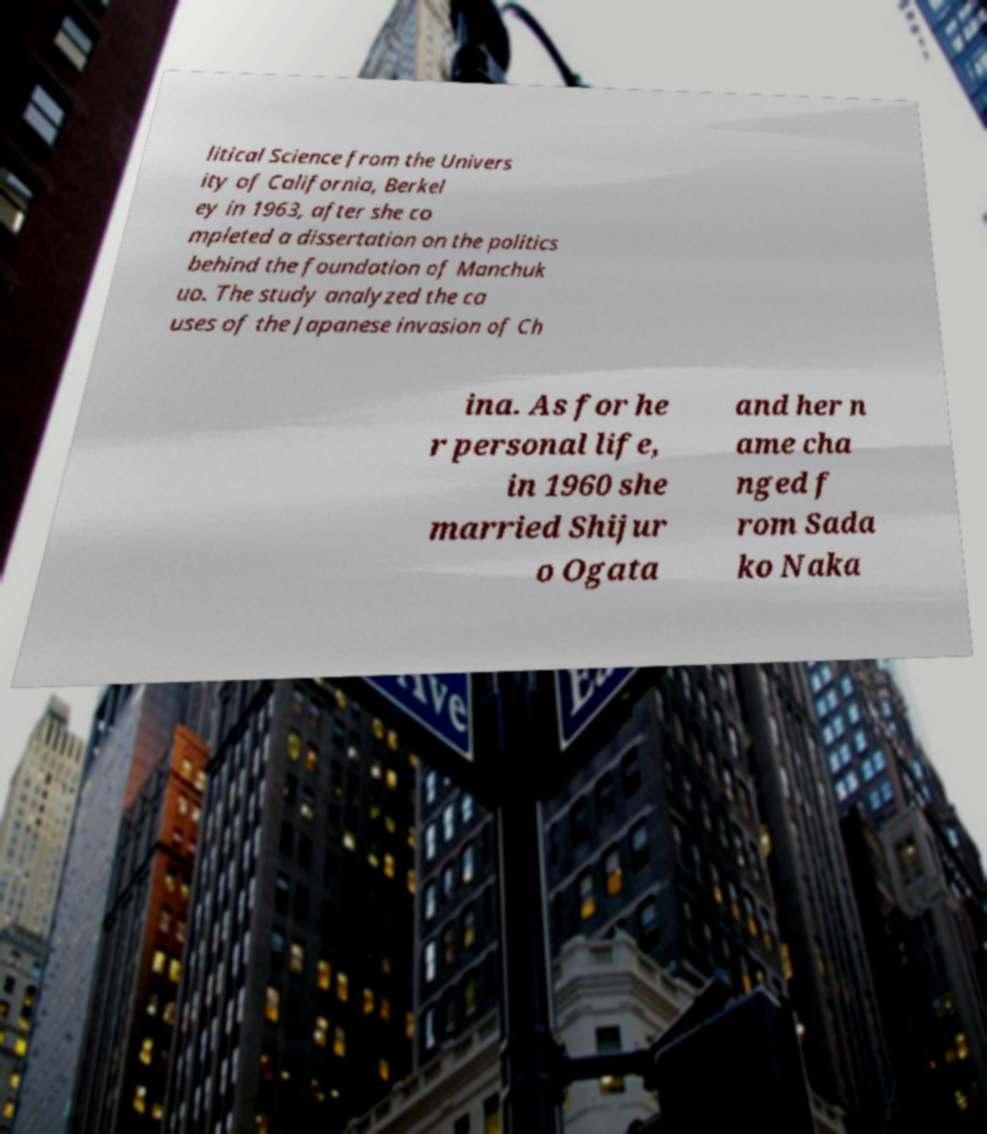Could you extract and type out the text from this image? litical Science from the Univers ity of California, Berkel ey in 1963, after she co mpleted a dissertation on the politics behind the foundation of Manchuk uo. The study analyzed the ca uses of the Japanese invasion of Ch ina. As for he r personal life, in 1960 she married Shijur o Ogata and her n ame cha nged f rom Sada ko Naka 